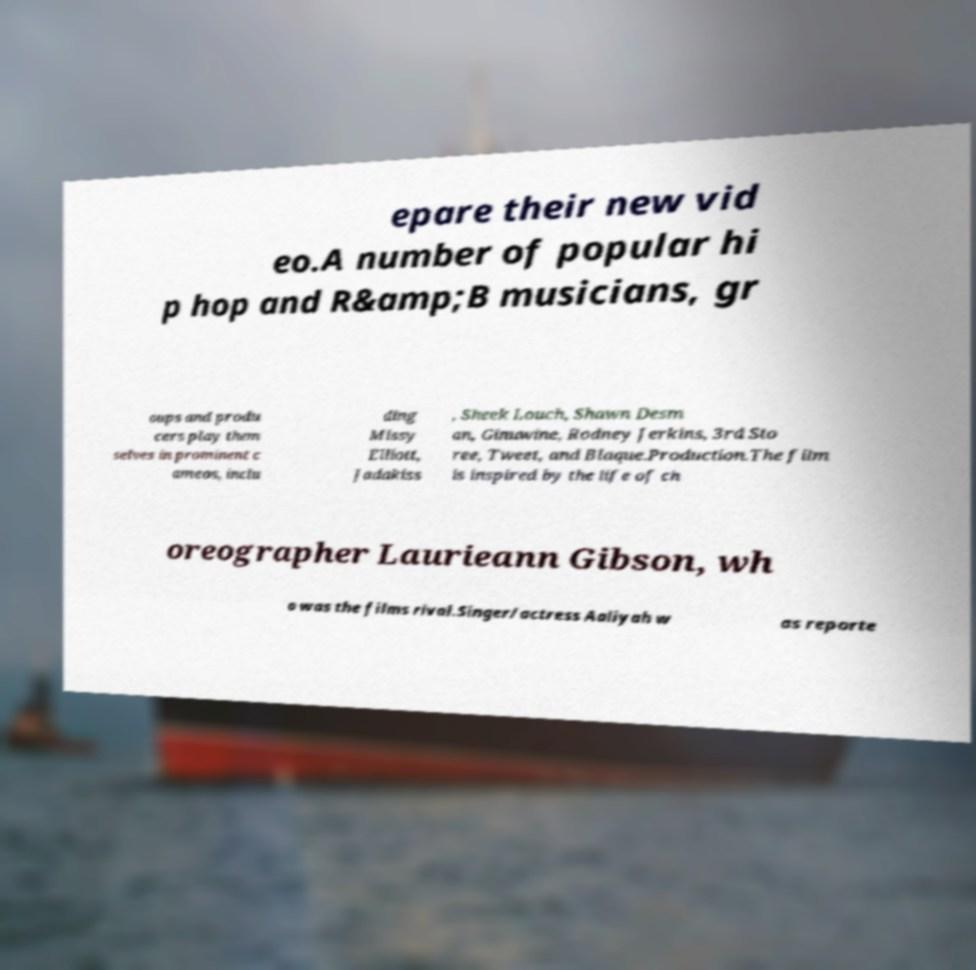Could you assist in decoding the text presented in this image and type it out clearly? epare their new vid eo.A number of popular hi p hop and R&amp;B musicians, gr oups and produ cers play them selves in prominent c ameos, inclu ding Missy Elliott, Jadakiss , Sheek Louch, Shawn Desm an, Ginuwine, Rodney Jerkins, 3rd Sto ree, Tweet, and Blaque.Production.The film is inspired by the life of ch oreographer Laurieann Gibson, wh o was the films rival.Singer/actress Aaliyah w as reporte 